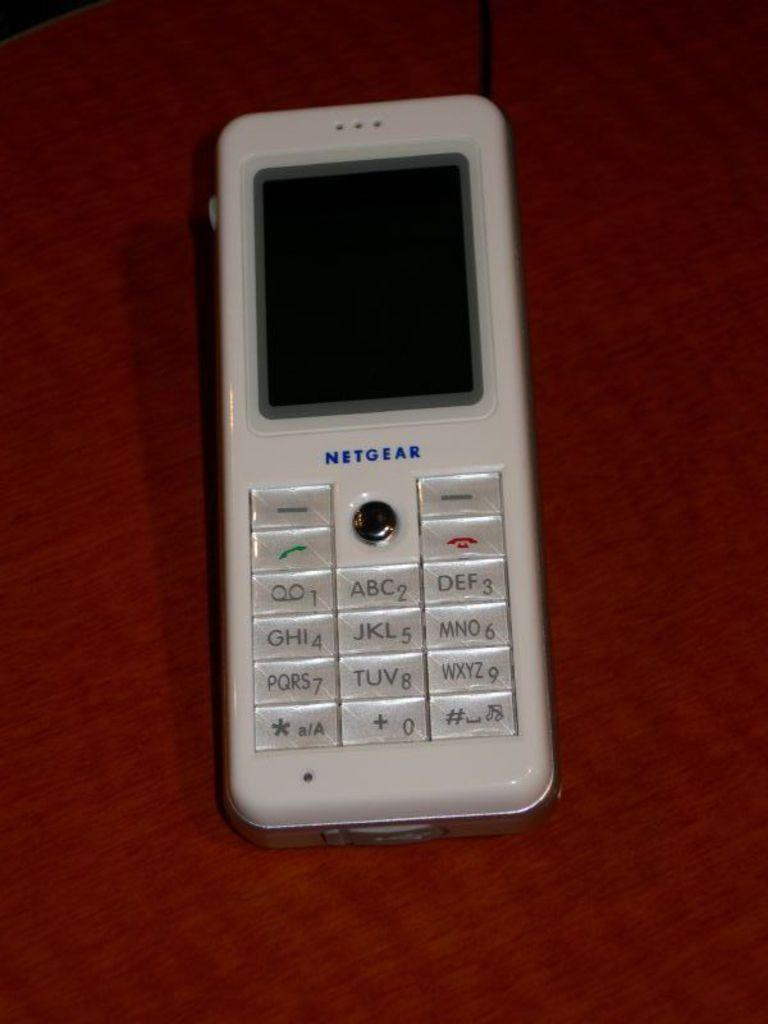<image>
Share a concise interpretation of the image provided. Many years ago, Netgear made miniature cell phones. 